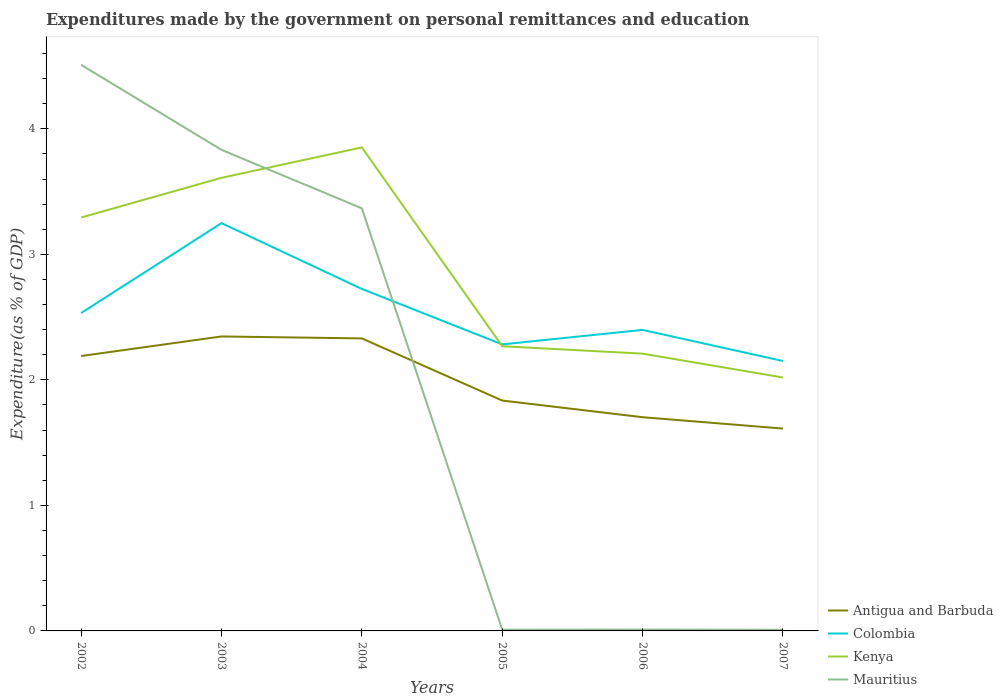Across all years, what is the maximum expenditures made by the government on personal remittances and education in Colombia?
Offer a terse response. 2.15. What is the total expenditures made by the government on personal remittances and education in Colombia in the graph?
Provide a succinct answer. 0.44. What is the difference between the highest and the second highest expenditures made by the government on personal remittances and education in Colombia?
Your response must be concise. 1.1. How many lines are there?
Provide a short and direct response. 4. Does the graph contain grids?
Offer a very short reply. No. Where does the legend appear in the graph?
Make the answer very short. Bottom right. What is the title of the graph?
Provide a succinct answer. Expenditures made by the government on personal remittances and education. What is the label or title of the X-axis?
Provide a succinct answer. Years. What is the label or title of the Y-axis?
Ensure brevity in your answer.  Expenditure(as % of GDP). What is the Expenditure(as % of GDP) of Antigua and Barbuda in 2002?
Offer a very short reply. 2.19. What is the Expenditure(as % of GDP) in Colombia in 2002?
Keep it short and to the point. 2.53. What is the Expenditure(as % of GDP) of Kenya in 2002?
Provide a succinct answer. 3.29. What is the Expenditure(as % of GDP) in Mauritius in 2002?
Provide a succinct answer. 4.51. What is the Expenditure(as % of GDP) of Antigua and Barbuda in 2003?
Keep it short and to the point. 2.35. What is the Expenditure(as % of GDP) in Colombia in 2003?
Your answer should be compact. 3.25. What is the Expenditure(as % of GDP) in Kenya in 2003?
Provide a succinct answer. 3.61. What is the Expenditure(as % of GDP) in Mauritius in 2003?
Offer a very short reply. 3.83. What is the Expenditure(as % of GDP) in Antigua and Barbuda in 2004?
Provide a succinct answer. 2.33. What is the Expenditure(as % of GDP) of Colombia in 2004?
Make the answer very short. 2.72. What is the Expenditure(as % of GDP) in Kenya in 2004?
Ensure brevity in your answer.  3.85. What is the Expenditure(as % of GDP) in Mauritius in 2004?
Provide a succinct answer. 3.37. What is the Expenditure(as % of GDP) in Antigua and Barbuda in 2005?
Your response must be concise. 1.84. What is the Expenditure(as % of GDP) in Colombia in 2005?
Make the answer very short. 2.28. What is the Expenditure(as % of GDP) of Kenya in 2005?
Your answer should be compact. 2.27. What is the Expenditure(as % of GDP) of Mauritius in 2005?
Give a very brief answer. 0.01. What is the Expenditure(as % of GDP) of Antigua and Barbuda in 2006?
Ensure brevity in your answer.  1.7. What is the Expenditure(as % of GDP) in Colombia in 2006?
Offer a terse response. 2.4. What is the Expenditure(as % of GDP) in Kenya in 2006?
Keep it short and to the point. 2.21. What is the Expenditure(as % of GDP) of Mauritius in 2006?
Give a very brief answer. 0.01. What is the Expenditure(as % of GDP) in Antigua and Barbuda in 2007?
Your answer should be compact. 1.61. What is the Expenditure(as % of GDP) in Colombia in 2007?
Give a very brief answer. 2.15. What is the Expenditure(as % of GDP) in Kenya in 2007?
Provide a succinct answer. 2.02. What is the Expenditure(as % of GDP) in Mauritius in 2007?
Provide a short and direct response. 0.01. Across all years, what is the maximum Expenditure(as % of GDP) in Antigua and Barbuda?
Give a very brief answer. 2.35. Across all years, what is the maximum Expenditure(as % of GDP) of Colombia?
Provide a succinct answer. 3.25. Across all years, what is the maximum Expenditure(as % of GDP) in Kenya?
Your answer should be very brief. 3.85. Across all years, what is the maximum Expenditure(as % of GDP) of Mauritius?
Ensure brevity in your answer.  4.51. Across all years, what is the minimum Expenditure(as % of GDP) of Antigua and Barbuda?
Provide a succinct answer. 1.61. Across all years, what is the minimum Expenditure(as % of GDP) of Colombia?
Give a very brief answer. 2.15. Across all years, what is the minimum Expenditure(as % of GDP) in Kenya?
Give a very brief answer. 2.02. Across all years, what is the minimum Expenditure(as % of GDP) in Mauritius?
Offer a very short reply. 0.01. What is the total Expenditure(as % of GDP) in Antigua and Barbuda in the graph?
Provide a short and direct response. 12.02. What is the total Expenditure(as % of GDP) of Colombia in the graph?
Ensure brevity in your answer.  15.34. What is the total Expenditure(as % of GDP) of Kenya in the graph?
Your response must be concise. 17.25. What is the total Expenditure(as % of GDP) in Mauritius in the graph?
Provide a short and direct response. 11.74. What is the difference between the Expenditure(as % of GDP) of Antigua and Barbuda in 2002 and that in 2003?
Make the answer very short. -0.16. What is the difference between the Expenditure(as % of GDP) of Colombia in 2002 and that in 2003?
Your response must be concise. -0.72. What is the difference between the Expenditure(as % of GDP) in Kenya in 2002 and that in 2003?
Your answer should be compact. -0.32. What is the difference between the Expenditure(as % of GDP) in Mauritius in 2002 and that in 2003?
Your response must be concise. 0.68. What is the difference between the Expenditure(as % of GDP) in Antigua and Barbuda in 2002 and that in 2004?
Your response must be concise. -0.14. What is the difference between the Expenditure(as % of GDP) of Colombia in 2002 and that in 2004?
Give a very brief answer. -0.19. What is the difference between the Expenditure(as % of GDP) of Kenya in 2002 and that in 2004?
Offer a terse response. -0.56. What is the difference between the Expenditure(as % of GDP) in Mauritius in 2002 and that in 2004?
Your answer should be very brief. 1.14. What is the difference between the Expenditure(as % of GDP) of Antigua and Barbuda in 2002 and that in 2005?
Your answer should be very brief. 0.35. What is the difference between the Expenditure(as % of GDP) in Colombia in 2002 and that in 2005?
Your answer should be very brief. 0.25. What is the difference between the Expenditure(as % of GDP) of Kenya in 2002 and that in 2005?
Keep it short and to the point. 1.03. What is the difference between the Expenditure(as % of GDP) of Mauritius in 2002 and that in 2005?
Your answer should be very brief. 4.5. What is the difference between the Expenditure(as % of GDP) of Antigua and Barbuda in 2002 and that in 2006?
Provide a short and direct response. 0.49. What is the difference between the Expenditure(as % of GDP) of Colombia in 2002 and that in 2006?
Provide a short and direct response. 0.13. What is the difference between the Expenditure(as % of GDP) of Kenya in 2002 and that in 2006?
Your answer should be compact. 1.08. What is the difference between the Expenditure(as % of GDP) of Mauritius in 2002 and that in 2006?
Give a very brief answer. 4.5. What is the difference between the Expenditure(as % of GDP) of Antigua and Barbuda in 2002 and that in 2007?
Offer a very short reply. 0.58. What is the difference between the Expenditure(as % of GDP) in Colombia in 2002 and that in 2007?
Provide a succinct answer. 0.38. What is the difference between the Expenditure(as % of GDP) in Kenya in 2002 and that in 2007?
Your answer should be very brief. 1.27. What is the difference between the Expenditure(as % of GDP) in Mauritius in 2002 and that in 2007?
Offer a terse response. 4.5. What is the difference between the Expenditure(as % of GDP) of Antigua and Barbuda in 2003 and that in 2004?
Your answer should be very brief. 0.02. What is the difference between the Expenditure(as % of GDP) in Colombia in 2003 and that in 2004?
Your response must be concise. 0.52. What is the difference between the Expenditure(as % of GDP) of Kenya in 2003 and that in 2004?
Provide a short and direct response. -0.24. What is the difference between the Expenditure(as % of GDP) in Mauritius in 2003 and that in 2004?
Ensure brevity in your answer.  0.47. What is the difference between the Expenditure(as % of GDP) of Antigua and Barbuda in 2003 and that in 2005?
Make the answer very short. 0.51. What is the difference between the Expenditure(as % of GDP) in Colombia in 2003 and that in 2005?
Provide a short and direct response. 0.97. What is the difference between the Expenditure(as % of GDP) of Kenya in 2003 and that in 2005?
Offer a very short reply. 1.34. What is the difference between the Expenditure(as % of GDP) of Mauritius in 2003 and that in 2005?
Offer a very short reply. 3.82. What is the difference between the Expenditure(as % of GDP) in Antigua and Barbuda in 2003 and that in 2006?
Your response must be concise. 0.64. What is the difference between the Expenditure(as % of GDP) of Colombia in 2003 and that in 2006?
Your answer should be very brief. 0.85. What is the difference between the Expenditure(as % of GDP) of Kenya in 2003 and that in 2006?
Keep it short and to the point. 1.4. What is the difference between the Expenditure(as % of GDP) in Mauritius in 2003 and that in 2006?
Provide a succinct answer. 3.82. What is the difference between the Expenditure(as % of GDP) of Antigua and Barbuda in 2003 and that in 2007?
Your response must be concise. 0.73. What is the difference between the Expenditure(as % of GDP) of Colombia in 2003 and that in 2007?
Offer a terse response. 1.1. What is the difference between the Expenditure(as % of GDP) in Kenya in 2003 and that in 2007?
Provide a succinct answer. 1.59. What is the difference between the Expenditure(as % of GDP) of Mauritius in 2003 and that in 2007?
Your answer should be compact. 3.82. What is the difference between the Expenditure(as % of GDP) in Antigua and Barbuda in 2004 and that in 2005?
Keep it short and to the point. 0.49. What is the difference between the Expenditure(as % of GDP) of Colombia in 2004 and that in 2005?
Provide a succinct answer. 0.44. What is the difference between the Expenditure(as % of GDP) in Kenya in 2004 and that in 2005?
Provide a short and direct response. 1.58. What is the difference between the Expenditure(as % of GDP) in Mauritius in 2004 and that in 2005?
Ensure brevity in your answer.  3.36. What is the difference between the Expenditure(as % of GDP) in Antigua and Barbuda in 2004 and that in 2006?
Offer a terse response. 0.63. What is the difference between the Expenditure(as % of GDP) of Colombia in 2004 and that in 2006?
Make the answer very short. 0.33. What is the difference between the Expenditure(as % of GDP) in Kenya in 2004 and that in 2006?
Keep it short and to the point. 1.64. What is the difference between the Expenditure(as % of GDP) of Mauritius in 2004 and that in 2006?
Keep it short and to the point. 3.36. What is the difference between the Expenditure(as % of GDP) of Antigua and Barbuda in 2004 and that in 2007?
Ensure brevity in your answer.  0.72. What is the difference between the Expenditure(as % of GDP) in Colombia in 2004 and that in 2007?
Provide a short and direct response. 0.57. What is the difference between the Expenditure(as % of GDP) in Kenya in 2004 and that in 2007?
Your answer should be compact. 1.83. What is the difference between the Expenditure(as % of GDP) in Mauritius in 2004 and that in 2007?
Provide a succinct answer. 3.36. What is the difference between the Expenditure(as % of GDP) in Antigua and Barbuda in 2005 and that in 2006?
Your response must be concise. 0.13. What is the difference between the Expenditure(as % of GDP) of Colombia in 2005 and that in 2006?
Make the answer very short. -0.12. What is the difference between the Expenditure(as % of GDP) of Kenya in 2005 and that in 2006?
Ensure brevity in your answer.  0.06. What is the difference between the Expenditure(as % of GDP) in Mauritius in 2005 and that in 2006?
Ensure brevity in your answer.  -0. What is the difference between the Expenditure(as % of GDP) in Antigua and Barbuda in 2005 and that in 2007?
Make the answer very short. 0.22. What is the difference between the Expenditure(as % of GDP) of Colombia in 2005 and that in 2007?
Provide a short and direct response. 0.13. What is the difference between the Expenditure(as % of GDP) in Kenya in 2005 and that in 2007?
Your answer should be very brief. 0.25. What is the difference between the Expenditure(as % of GDP) in Mauritius in 2005 and that in 2007?
Provide a succinct answer. 0. What is the difference between the Expenditure(as % of GDP) in Antigua and Barbuda in 2006 and that in 2007?
Your answer should be very brief. 0.09. What is the difference between the Expenditure(as % of GDP) of Colombia in 2006 and that in 2007?
Provide a succinct answer. 0.25. What is the difference between the Expenditure(as % of GDP) in Kenya in 2006 and that in 2007?
Your response must be concise. 0.19. What is the difference between the Expenditure(as % of GDP) in Mauritius in 2006 and that in 2007?
Make the answer very short. 0. What is the difference between the Expenditure(as % of GDP) of Antigua and Barbuda in 2002 and the Expenditure(as % of GDP) of Colombia in 2003?
Your answer should be very brief. -1.06. What is the difference between the Expenditure(as % of GDP) in Antigua and Barbuda in 2002 and the Expenditure(as % of GDP) in Kenya in 2003?
Your answer should be compact. -1.42. What is the difference between the Expenditure(as % of GDP) of Antigua and Barbuda in 2002 and the Expenditure(as % of GDP) of Mauritius in 2003?
Your answer should be compact. -1.64. What is the difference between the Expenditure(as % of GDP) of Colombia in 2002 and the Expenditure(as % of GDP) of Kenya in 2003?
Provide a succinct answer. -1.08. What is the difference between the Expenditure(as % of GDP) in Colombia in 2002 and the Expenditure(as % of GDP) in Mauritius in 2003?
Give a very brief answer. -1.3. What is the difference between the Expenditure(as % of GDP) of Kenya in 2002 and the Expenditure(as % of GDP) of Mauritius in 2003?
Your answer should be compact. -0.54. What is the difference between the Expenditure(as % of GDP) of Antigua and Barbuda in 2002 and the Expenditure(as % of GDP) of Colombia in 2004?
Provide a short and direct response. -0.53. What is the difference between the Expenditure(as % of GDP) in Antigua and Barbuda in 2002 and the Expenditure(as % of GDP) in Kenya in 2004?
Offer a very short reply. -1.66. What is the difference between the Expenditure(as % of GDP) in Antigua and Barbuda in 2002 and the Expenditure(as % of GDP) in Mauritius in 2004?
Give a very brief answer. -1.18. What is the difference between the Expenditure(as % of GDP) of Colombia in 2002 and the Expenditure(as % of GDP) of Kenya in 2004?
Offer a terse response. -1.32. What is the difference between the Expenditure(as % of GDP) in Colombia in 2002 and the Expenditure(as % of GDP) in Mauritius in 2004?
Your response must be concise. -0.83. What is the difference between the Expenditure(as % of GDP) in Kenya in 2002 and the Expenditure(as % of GDP) in Mauritius in 2004?
Offer a very short reply. -0.07. What is the difference between the Expenditure(as % of GDP) in Antigua and Barbuda in 2002 and the Expenditure(as % of GDP) in Colombia in 2005?
Keep it short and to the point. -0.09. What is the difference between the Expenditure(as % of GDP) in Antigua and Barbuda in 2002 and the Expenditure(as % of GDP) in Kenya in 2005?
Make the answer very short. -0.08. What is the difference between the Expenditure(as % of GDP) in Antigua and Barbuda in 2002 and the Expenditure(as % of GDP) in Mauritius in 2005?
Provide a succinct answer. 2.18. What is the difference between the Expenditure(as % of GDP) of Colombia in 2002 and the Expenditure(as % of GDP) of Kenya in 2005?
Keep it short and to the point. 0.26. What is the difference between the Expenditure(as % of GDP) of Colombia in 2002 and the Expenditure(as % of GDP) of Mauritius in 2005?
Provide a short and direct response. 2.52. What is the difference between the Expenditure(as % of GDP) in Kenya in 2002 and the Expenditure(as % of GDP) in Mauritius in 2005?
Ensure brevity in your answer.  3.28. What is the difference between the Expenditure(as % of GDP) of Antigua and Barbuda in 2002 and the Expenditure(as % of GDP) of Colombia in 2006?
Keep it short and to the point. -0.21. What is the difference between the Expenditure(as % of GDP) of Antigua and Barbuda in 2002 and the Expenditure(as % of GDP) of Kenya in 2006?
Give a very brief answer. -0.02. What is the difference between the Expenditure(as % of GDP) in Antigua and Barbuda in 2002 and the Expenditure(as % of GDP) in Mauritius in 2006?
Provide a short and direct response. 2.18. What is the difference between the Expenditure(as % of GDP) in Colombia in 2002 and the Expenditure(as % of GDP) in Kenya in 2006?
Offer a very short reply. 0.32. What is the difference between the Expenditure(as % of GDP) of Colombia in 2002 and the Expenditure(as % of GDP) of Mauritius in 2006?
Your answer should be compact. 2.52. What is the difference between the Expenditure(as % of GDP) in Kenya in 2002 and the Expenditure(as % of GDP) in Mauritius in 2006?
Your response must be concise. 3.28. What is the difference between the Expenditure(as % of GDP) of Antigua and Barbuda in 2002 and the Expenditure(as % of GDP) of Colombia in 2007?
Offer a very short reply. 0.04. What is the difference between the Expenditure(as % of GDP) of Antigua and Barbuda in 2002 and the Expenditure(as % of GDP) of Kenya in 2007?
Give a very brief answer. 0.17. What is the difference between the Expenditure(as % of GDP) of Antigua and Barbuda in 2002 and the Expenditure(as % of GDP) of Mauritius in 2007?
Keep it short and to the point. 2.18. What is the difference between the Expenditure(as % of GDP) in Colombia in 2002 and the Expenditure(as % of GDP) in Kenya in 2007?
Offer a very short reply. 0.51. What is the difference between the Expenditure(as % of GDP) in Colombia in 2002 and the Expenditure(as % of GDP) in Mauritius in 2007?
Keep it short and to the point. 2.52. What is the difference between the Expenditure(as % of GDP) of Kenya in 2002 and the Expenditure(as % of GDP) of Mauritius in 2007?
Your answer should be compact. 3.28. What is the difference between the Expenditure(as % of GDP) in Antigua and Barbuda in 2003 and the Expenditure(as % of GDP) in Colombia in 2004?
Your answer should be compact. -0.38. What is the difference between the Expenditure(as % of GDP) in Antigua and Barbuda in 2003 and the Expenditure(as % of GDP) in Kenya in 2004?
Offer a very short reply. -1.51. What is the difference between the Expenditure(as % of GDP) in Antigua and Barbuda in 2003 and the Expenditure(as % of GDP) in Mauritius in 2004?
Provide a short and direct response. -1.02. What is the difference between the Expenditure(as % of GDP) of Colombia in 2003 and the Expenditure(as % of GDP) of Kenya in 2004?
Make the answer very short. -0.6. What is the difference between the Expenditure(as % of GDP) of Colombia in 2003 and the Expenditure(as % of GDP) of Mauritius in 2004?
Ensure brevity in your answer.  -0.12. What is the difference between the Expenditure(as % of GDP) of Kenya in 2003 and the Expenditure(as % of GDP) of Mauritius in 2004?
Your answer should be very brief. 0.24. What is the difference between the Expenditure(as % of GDP) in Antigua and Barbuda in 2003 and the Expenditure(as % of GDP) in Colombia in 2005?
Your answer should be compact. 0.06. What is the difference between the Expenditure(as % of GDP) of Antigua and Barbuda in 2003 and the Expenditure(as % of GDP) of Kenya in 2005?
Provide a short and direct response. 0.08. What is the difference between the Expenditure(as % of GDP) of Antigua and Barbuda in 2003 and the Expenditure(as % of GDP) of Mauritius in 2005?
Your answer should be compact. 2.34. What is the difference between the Expenditure(as % of GDP) of Colombia in 2003 and the Expenditure(as % of GDP) of Kenya in 2005?
Make the answer very short. 0.98. What is the difference between the Expenditure(as % of GDP) in Colombia in 2003 and the Expenditure(as % of GDP) in Mauritius in 2005?
Ensure brevity in your answer.  3.24. What is the difference between the Expenditure(as % of GDP) in Kenya in 2003 and the Expenditure(as % of GDP) in Mauritius in 2005?
Offer a very short reply. 3.6. What is the difference between the Expenditure(as % of GDP) of Antigua and Barbuda in 2003 and the Expenditure(as % of GDP) of Colombia in 2006?
Provide a succinct answer. -0.05. What is the difference between the Expenditure(as % of GDP) of Antigua and Barbuda in 2003 and the Expenditure(as % of GDP) of Kenya in 2006?
Your answer should be very brief. 0.14. What is the difference between the Expenditure(as % of GDP) of Antigua and Barbuda in 2003 and the Expenditure(as % of GDP) of Mauritius in 2006?
Make the answer very short. 2.34. What is the difference between the Expenditure(as % of GDP) in Colombia in 2003 and the Expenditure(as % of GDP) in Kenya in 2006?
Your response must be concise. 1.04. What is the difference between the Expenditure(as % of GDP) in Colombia in 2003 and the Expenditure(as % of GDP) in Mauritius in 2006?
Your answer should be very brief. 3.24. What is the difference between the Expenditure(as % of GDP) in Kenya in 2003 and the Expenditure(as % of GDP) in Mauritius in 2006?
Give a very brief answer. 3.6. What is the difference between the Expenditure(as % of GDP) in Antigua and Barbuda in 2003 and the Expenditure(as % of GDP) in Colombia in 2007?
Offer a terse response. 0.2. What is the difference between the Expenditure(as % of GDP) in Antigua and Barbuda in 2003 and the Expenditure(as % of GDP) in Kenya in 2007?
Your answer should be compact. 0.33. What is the difference between the Expenditure(as % of GDP) in Antigua and Barbuda in 2003 and the Expenditure(as % of GDP) in Mauritius in 2007?
Your answer should be very brief. 2.34. What is the difference between the Expenditure(as % of GDP) of Colombia in 2003 and the Expenditure(as % of GDP) of Kenya in 2007?
Your answer should be very brief. 1.23. What is the difference between the Expenditure(as % of GDP) of Colombia in 2003 and the Expenditure(as % of GDP) of Mauritius in 2007?
Provide a short and direct response. 3.24. What is the difference between the Expenditure(as % of GDP) of Kenya in 2003 and the Expenditure(as % of GDP) of Mauritius in 2007?
Your answer should be very brief. 3.6. What is the difference between the Expenditure(as % of GDP) in Antigua and Barbuda in 2004 and the Expenditure(as % of GDP) in Colombia in 2005?
Keep it short and to the point. 0.05. What is the difference between the Expenditure(as % of GDP) of Antigua and Barbuda in 2004 and the Expenditure(as % of GDP) of Kenya in 2005?
Provide a short and direct response. 0.06. What is the difference between the Expenditure(as % of GDP) of Antigua and Barbuda in 2004 and the Expenditure(as % of GDP) of Mauritius in 2005?
Offer a terse response. 2.32. What is the difference between the Expenditure(as % of GDP) in Colombia in 2004 and the Expenditure(as % of GDP) in Kenya in 2005?
Provide a succinct answer. 0.46. What is the difference between the Expenditure(as % of GDP) in Colombia in 2004 and the Expenditure(as % of GDP) in Mauritius in 2005?
Provide a succinct answer. 2.71. What is the difference between the Expenditure(as % of GDP) of Kenya in 2004 and the Expenditure(as % of GDP) of Mauritius in 2005?
Your answer should be very brief. 3.84. What is the difference between the Expenditure(as % of GDP) in Antigua and Barbuda in 2004 and the Expenditure(as % of GDP) in Colombia in 2006?
Offer a very short reply. -0.07. What is the difference between the Expenditure(as % of GDP) in Antigua and Barbuda in 2004 and the Expenditure(as % of GDP) in Kenya in 2006?
Offer a very short reply. 0.12. What is the difference between the Expenditure(as % of GDP) of Antigua and Barbuda in 2004 and the Expenditure(as % of GDP) of Mauritius in 2006?
Keep it short and to the point. 2.32. What is the difference between the Expenditure(as % of GDP) in Colombia in 2004 and the Expenditure(as % of GDP) in Kenya in 2006?
Ensure brevity in your answer.  0.52. What is the difference between the Expenditure(as % of GDP) of Colombia in 2004 and the Expenditure(as % of GDP) of Mauritius in 2006?
Your answer should be compact. 2.71. What is the difference between the Expenditure(as % of GDP) in Kenya in 2004 and the Expenditure(as % of GDP) in Mauritius in 2006?
Give a very brief answer. 3.84. What is the difference between the Expenditure(as % of GDP) of Antigua and Barbuda in 2004 and the Expenditure(as % of GDP) of Colombia in 2007?
Give a very brief answer. 0.18. What is the difference between the Expenditure(as % of GDP) of Antigua and Barbuda in 2004 and the Expenditure(as % of GDP) of Kenya in 2007?
Ensure brevity in your answer.  0.31. What is the difference between the Expenditure(as % of GDP) of Antigua and Barbuda in 2004 and the Expenditure(as % of GDP) of Mauritius in 2007?
Offer a terse response. 2.32. What is the difference between the Expenditure(as % of GDP) of Colombia in 2004 and the Expenditure(as % of GDP) of Kenya in 2007?
Ensure brevity in your answer.  0.71. What is the difference between the Expenditure(as % of GDP) of Colombia in 2004 and the Expenditure(as % of GDP) of Mauritius in 2007?
Offer a terse response. 2.72. What is the difference between the Expenditure(as % of GDP) in Kenya in 2004 and the Expenditure(as % of GDP) in Mauritius in 2007?
Give a very brief answer. 3.84. What is the difference between the Expenditure(as % of GDP) in Antigua and Barbuda in 2005 and the Expenditure(as % of GDP) in Colombia in 2006?
Offer a very short reply. -0.56. What is the difference between the Expenditure(as % of GDP) of Antigua and Barbuda in 2005 and the Expenditure(as % of GDP) of Kenya in 2006?
Give a very brief answer. -0.37. What is the difference between the Expenditure(as % of GDP) in Antigua and Barbuda in 2005 and the Expenditure(as % of GDP) in Mauritius in 2006?
Your response must be concise. 1.82. What is the difference between the Expenditure(as % of GDP) of Colombia in 2005 and the Expenditure(as % of GDP) of Kenya in 2006?
Provide a succinct answer. 0.07. What is the difference between the Expenditure(as % of GDP) in Colombia in 2005 and the Expenditure(as % of GDP) in Mauritius in 2006?
Provide a short and direct response. 2.27. What is the difference between the Expenditure(as % of GDP) of Kenya in 2005 and the Expenditure(as % of GDP) of Mauritius in 2006?
Offer a terse response. 2.26. What is the difference between the Expenditure(as % of GDP) of Antigua and Barbuda in 2005 and the Expenditure(as % of GDP) of Colombia in 2007?
Provide a succinct answer. -0.32. What is the difference between the Expenditure(as % of GDP) in Antigua and Barbuda in 2005 and the Expenditure(as % of GDP) in Kenya in 2007?
Your answer should be compact. -0.18. What is the difference between the Expenditure(as % of GDP) of Antigua and Barbuda in 2005 and the Expenditure(as % of GDP) of Mauritius in 2007?
Give a very brief answer. 1.83. What is the difference between the Expenditure(as % of GDP) in Colombia in 2005 and the Expenditure(as % of GDP) in Kenya in 2007?
Provide a succinct answer. 0.26. What is the difference between the Expenditure(as % of GDP) in Colombia in 2005 and the Expenditure(as % of GDP) in Mauritius in 2007?
Your answer should be compact. 2.27. What is the difference between the Expenditure(as % of GDP) in Kenya in 2005 and the Expenditure(as % of GDP) in Mauritius in 2007?
Your answer should be compact. 2.26. What is the difference between the Expenditure(as % of GDP) of Antigua and Barbuda in 2006 and the Expenditure(as % of GDP) of Colombia in 2007?
Keep it short and to the point. -0.45. What is the difference between the Expenditure(as % of GDP) in Antigua and Barbuda in 2006 and the Expenditure(as % of GDP) in Kenya in 2007?
Give a very brief answer. -0.32. What is the difference between the Expenditure(as % of GDP) in Antigua and Barbuda in 2006 and the Expenditure(as % of GDP) in Mauritius in 2007?
Offer a terse response. 1.69. What is the difference between the Expenditure(as % of GDP) in Colombia in 2006 and the Expenditure(as % of GDP) in Kenya in 2007?
Your response must be concise. 0.38. What is the difference between the Expenditure(as % of GDP) in Colombia in 2006 and the Expenditure(as % of GDP) in Mauritius in 2007?
Your answer should be compact. 2.39. What is the difference between the Expenditure(as % of GDP) in Kenya in 2006 and the Expenditure(as % of GDP) in Mauritius in 2007?
Offer a terse response. 2.2. What is the average Expenditure(as % of GDP) in Antigua and Barbuda per year?
Your response must be concise. 2. What is the average Expenditure(as % of GDP) in Colombia per year?
Make the answer very short. 2.56. What is the average Expenditure(as % of GDP) in Kenya per year?
Ensure brevity in your answer.  2.88. What is the average Expenditure(as % of GDP) of Mauritius per year?
Make the answer very short. 1.96. In the year 2002, what is the difference between the Expenditure(as % of GDP) of Antigua and Barbuda and Expenditure(as % of GDP) of Colombia?
Your response must be concise. -0.34. In the year 2002, what is the difference between the Expenditure(as % of GDP) in Antigua and Barbuda and Expenditure(as % of GDP) in Kenya?
Provide a succinct answer. -1.1. In the year 2002, what is the difference between the Expenditure(as % of GDP) in Antigua and Barbuda and Expenditure(as % of GDP) in Mauritius?
Give a very brief answer. -2.32. In the year 2002, what is the difference between the Expenditure(as % of GDP) in Colombia and Expenditure(as % of GDP) in Kenya?
Give a very brief answer. -0.76. In the year 2002, what is the difference between the Expenditure(as % of GDP) in Colombia and Expenditure(as % of GDP) in Mauritius?
Offer a very short reply. -1.98. In the year 2002, what is the difference between the Expenditure(as % of GDP) of Kenya and Expenditure(as % of GDP) of Mauritius?
Provide a succinct answer. -1.22. In the year 2003, what is the difference between the Expenditure(as % of GDP) in Antigua and Barbuda and Expenditure(as % of GDP) in Colombia?
Provide a succinct answer. -0.9. In the year 2003, what is the difference between the Expenditure(as % of GDP) in Antigua and Barbuda and Expenditure(as % of GDP) in Kenya?
Provide a short and direct response. -1.26. In the year 2003, what is the difference between the Expenditure(as % of GDP) in Antigua and Barbuda and Expenditure(as % of GDP) in Mauritius?
Your answer should be compact. -1.49. In the year 2003, what is the difference between the Expenditure(as % of GDP) of Colombia and Expenditure(as % of GDP) of Kenya?
Offer a very short reply. -0.36. In the year 2003, what is the difference between the Expenditure(as % of GDP) of Colombia and Expenditure(as % of GDP) of Mauritius?
Provide a short and direct response. -0.58. In the year 2003, what is the difference between the Expenditure(as % of GDP) of Kenya and Expenditure(as % of GDP) of Mauritius?
Offer a very short reply. -0.22. In the year 2004, what is the difference between the Expenditure(as % of GDP) in Antigua and Barbuda and Expenditure(as % of GDP) in Colombia?
Make the answer very short. -0.39. In the year 2004, what is the difference between the Expenditure(as % of GDP) of Antigua and Barbuda and Expenditure(as % of GDP) of Kenya?
Your answer should be very brief. -1.52. In the year 2004, what is the difference between the Expenditure(as % of GDP) in Antigua and Barbuda and Expenditure(as % of GDP) in Mauritius?
Offer a terse response. -1.04. In the year 2004, what is the difference between the Expenditure(as % of GDP) in Colombia and Expenditure(as % of GDP) in Kenya?
Keep it short and to the point. -1.13. In the year 2004, what is the difference between the Expenditure(as % of GDP) of Colombia and Expenditure(as % of GDP) of Mauritius?
Your answer should be compact. -0.64. In the year 2004, what is the difference between the Expenditure(as % of GDP) in Kenya and Expenditure(as % of GDP) in Mauritius?
Ensure brevity in your answer.  0.49. In the year 2005, what is the difference between the Expenditure(as % of GDP) of Antigua and Barbuda and Expenditure(as % of GDP) of Colombia?
Your response must be concise. -0.45. In the year 2005, what is the difference between the Expenditure(as % of GDP) of Antigua and Barbuda and Expenditure(as % of GDP) of Kenya?
Offer a very short reply. -0.43. In the year 2005, what is the difference between the Expenditure(as % of GDP) in Antigua and Barbuda and Expenditure(as % of GDP) in Mauritius?
Provide a short and direct response. 1.83. In the year 2005, what is the difference between the Expenditure(as % of GDP) of Colombia and Expenditure(as % of GDP) of Kenya?
Your response must be concise. 0.01. In the year 2005, what is the difference between the Expenditure(as % of GDP) of Colombia and Expenditure(as % of GDP) of Mauritius?
Make the answer very short. 2.27. In the year 2005, what is the difference between the Expenditure(as % of GDP) of Kenya and Expenditure(as % of GDP) of Mauritius?
Offer a very short reply. 2.26. In the year 2006, what is the difference between the Expenditure(as % of GDP) of Antigua and Barbuda and Expenditure(as % of GDP) of Colombia?
Your answer should be compact. -0.7. In the year 2006, what is the difference between the Expenditure(as % of GDP) in Antigua and Barbuda and Expenditure(as % of GDP) in Kenya?
Offer a terse response. -0.51. In the year 2006, what is the difference between the Expenditure(as % of GDP) of Antigua and Barbuda and Expenditure(as % of GDP) of Mauritius?
Provide a short and direct response. 1.69. In the year 2006, what is the difference between the Expenditure(as % of GDP) in Colombia and Expenditure(as % of GDP) in Kenya?
Offer a very short reply. 0.19. In the year 2006, what is the difference between the Expenditure(as % of GDP) of Colombia and Expenditure(as % of GDP) of Mauritius?
Keep it short and to the point. 2.39. In the year 2006, what is the difference between the Expenditure(as % of GDP) in Kenya and Expenditure(as % of GDP) in Mauritius?
Your answer should be very brief. 2.2. In the year 2007, what is the difference between the Expenditure(as % of GDP) in Antigua and Barbuda and Expenditure(as % of GDP) in Colombia?
Make the answer very short. -0.54. In the year 2007, what is the difference between the Expenditure(as % of GDP) in Antigua and Barbuda and Expenditure(as % of GDP) in Kenya?
Your answer should be very brief. -0.41. In the year 2007, what is the difference between the Expenditure(as % of GDP) in Antigua and Barbuda and Expenditure(as % of GDP) in Mauritius?
Your answer should be compact. 1.6. In the year 2007, what is the difference between the Expenditure(as % of GDP) in Colombia and Expenditure(as % of GDP) in Kenya?
Give a very brief answer. 0.13. In the year 2007, what is the difference between the Expenditure(as % of GDP) of Colombia and Expenditure(as % of GDP) of Mauritius?
Your answer should be compact. 2.14. In the year 2007, what is the difference between the Expenditure(as % of GDP) of Kenya and Expenditure(as % of GDP) of Mauritius?
Your answer should be very brief. 2.01. What is the ratio of the Expenditure(as % of GDP) in Antigua and Barbuda in 2002 to that in 2003?
Your answer should be very brief. 0.93. What is the ratio of the Expenditure(as % of GDP) in Colombia in 2002 to that in 2003?
Provide a succinct answer. 0.78. What is the ratio of the Expenditure(as % of GDP) in Kenya in 2002 to that in 2003?
Your answer should be very brief. 0.91. What is the ratio of the Expenditure(as % of GDP) of Mauritius in 2002 to that in 2003?
Your answer should be compact. 1.18. What is the ratio of the Expenditure(as % of GDP) of Antigua and Barbuda in 2002 to that in 2004?
Provide a short and direct response. 0.94. What is the ratio of the Expenditure(as % of GDP) of Colombia in 2002 to that in 2004?
Make the answer very short. 0.93. What is the ratio of the Expenditure(as % of GDP) of Kenya in 2002 to that in 2004?
Your answer should be very brief. 0.85. What is the ratio of the Expenditure(as % of GDP) in Mauritius in 2002 to that in 2004?
Provide a short and direct response. 1.34. What is the ratio of the Expenditure(as % of GDP) in Antigua and Barbuda in 2002 to that in 2005?
Offer a terse response. 1.19. What is the ratio of the Expenditure(as % of GDP) in Colombia in 2002 to that in 2005?
Ensure brevity in your answer.  1.11. What is the ratio of the Expenditure(as % of GDP) in Kenya in 2002 to that in 2005?
Give a very brief answer. 1.45. What is the ratio of the Expenditure(as % of GDP) of Mauritius in 2002 to that in 2005?
Your response must be concise. 465.19. What is the ratio of the Expenditure(as % of GDP) in Antigua and Barbuda in 2002 to that in 2006?
Give a very brief answer. 1.29. What is the ratio of the Expenditure(as % of GDP) of Colombia in 2002 to that in 2006?
Your answer should be compact. 1.06. What is the ratio of the Expenditure(as % of GDP) in Kenya in 2002 to that in 2006?
Give a very brief answer. 1.49. What is the ratio of the Expenditure(as % of GDP) of Mauritius in 2002 to that in 2006?
Your answer should be compact. 416.55. What is the ratio of the Expenditure(as % of GDP) of Antigua and Barbuda in 2002 to that in 2007?
Your answer should be very brief. 1.36. What is the ratio of the Expenditure(as % of GDP) of Colombia in 2002 to that in 2007?
Provide a short and direct response. 1.18. What is the ratio of the Expenditure(as % of GDP) of Kenya in 2002 to that in 2007?
Give a very brief answer. 1.63. What is the ratio of the Expenditure(as % of GDP) in Mauritius in 2002 to that in 2007?
Make the answer very short. 499.45. What is the ratio of the Expenditure(as % of GDP) of Colombia in 2003 to that in 2004?
Your response must be concise. 1.19. What is the ratio of the Expenditure(as % of GDP) in Kenya in 2003 to that in 2004?
Ensure brevity in your answer.  0.94. What is the ratio of the Expenditure(as % of GDP) in Mauritius in 2003 to that in 2004?
Offer a terse response. 1.14. What is the ratio of the Expenditure(as % of GDP) of Antigua and Barbuda in 2003 to that in 2005?
Keep it short and to the point. 1.28. What is the ratio of the Expenditure(as % of GDP) of Colombia in 2003 to that in 2005?
Offer a very short reply. 1.42. What is the ratio of the Expenditure(as % of GDP) in Kenya in 2003 to that in 2005?
Ensure brevity in your answer.  1.59. What is the ratio of the Expenditure(as % of GDP) in Mauritius in 2003 to that in 2005?
Offer a terse response. 395.33. What is the ratio of the Expenditure(as % of GDP) in Antigua and Barbuda in 2003 to that in 2006?
Provide a short and direct response. 1.38. What is the ratio of the Expenditure(as % of GDP) in Colombia in 2003 to that in 2006?
Give a very brief answer. 1.35. What is the ratio of the Expenditure(as % of GDP) of Kenya in 2003 to that in 2006?
Make the answer very short. 1.63. What is the ratio of the Expenditure(as % of GDP) of Mauritius in 2003 to that in 2006?
Offer a terse response. 353.99. What is the ratio of the Expenditure(as % of GDP) in Antigua and Barbuda in 2003 to that in 2007?
Keep it short and to the point. 1.46. What is the ratio of the Expenditure(as % of GDP) in Colombia in 2003 to that in 2007?
Your answer should be compact. 1.51. What is the ratio of the Expenditure(as % of GDP) in Kenya in 2003 to that in 2007?
Your answer should be compact. 1.79. What is the ratio of the Expenditure(as % of GDP) of Mauritius in 2003 to that in 2007?
Give a very brief answer. 424.44. What is the ratio of the Expenditure(as % of GDP) of Antigua and Barbuda in 2004 to that in 2005?
Provide a short and direct response. 1.27. What is the ratio of the Expenditure(as % of GDP) in Colombia in 2004 to that in 2005?
Your response must be concise. 1.19. What is the ratio of the Expenditure(as % of GDP) of Kenya in 2004 to that in 2005?
Ensure brevity in your answer.  1.7. What is the ratio of the Expenditure(as % of GDP) in Mauritius in 2004 to that in 2005?
Ensure brevity in your answer.  347.29. What is the ratio of the Expenditure(as % of GDP) of Antigua and Barbuda in 2004 to that in 2006?
Give a very brief answer. 1.37. What is the ratio of the Expenditure(as % of GDP) of Colombia in 2004 to that in 2006?
Offer a very short reply. 1.14. What is the ratio of the Expenditure(as % of GDP) in Kenya in 2004 to that in 2006?
Give a very brief answer. 1.74. What is the ratio of the Expenditure(as % of GDP) in Mauritius in 2004 to that in 2006?
Make the answer very short. 310.98. What is the ratio of the Expenditure(as % of GDP) in Antigua and Barbuda in 2004 to that in 2007?
Your answer should be very brief. 1.45. What is the ratio of the Expenditure(as % of GDP) of Colombia in 2004 to that in 2007?
Make the answer very short. 1.27. What is the ratio of the Expenditure(as % of GDP) of Kenya in 2004 to that in 2007?
Ensure brevity in your answer.  1.91. What is the ratio of the Expenditure(as % of GDP) of Mauritius in 2004 to that in 2007?
Your answer should be compact. 372.87. What is the ratio of the Expenditure(as % of GDP) in Antigua and Barbuda in 2005 to that in 2006?
Your answer should be compact. 1.08. What is the ratio of the Expenditure(as % of GDP) in Colombia in 2005 to that in 2006?
Give a very brief answer. 0.95. What is the ratio of the Expenditure(as % of GDP) in Kenya in 2005 to that in 2006?
Keep it short and to the point. 1.03. What is the ratio of the Expenditure(as % of GDP) in Mauritius in 2005 to that in 2006?
Offer a very short reply. 0.9. What is the ratio of the Expenditure(as % of GDP) of Antigua and Barbuda in 2005 to that in 2007?
Offer a very short reply. 1.14. What is the ratio of the Expenditure(as % of GDP) of Colombia in 2005 to that in 2007?
Offer a very short reply. 1.06. What is the ratio of the Expenditure(as % of GDP) of Kenya in 2005 to that in 2007?
Your answer should be compact. 1.12. What is the ratio of the Expenditure(as % of GDP) of Mauritius in 2005 to that in 2007?
Your response must be concise. 1.07. What is the ratio of the Expenditure(as % of GDP) of Antigua and Barbuda in 2006 to that in 2007?
Ensure brevity in your answer.  1.06. What is the ratio of the Expenditure(as % of GDP) in Colombia in 2006 to that in 2007?
Offer a very short reply. 1.12. What is the ratio of the Expenditure(as % of GDP) in Kenya in 2006 to that in 2007?
Your response must be concise. 1.09. What is the ratio of the Expenditure(as % of GDP) of Mauritius in 2006 to that in 2007?
Give a very brief answer. 1.2. What is the difference between the highest and the second highest Expenditure(as % of GDP) of Antigua and Barbuda?
Give a very brief answer. 0.02. What is the difference between the highest and the second highest Expenditure(as % of GDP) in Colombia?
Your response must be concise. 0.52. What is the difference between the highest and the second highest Expenditure(as % of GDP) of Kenya?
Keep it short and to the point. 0.24. What is the difference between the highest and the second highest Expenditure(as % of GDP) of Mauritius?
Give a very brief answer. 0.68. What is the difference between the highest and the lowest Expenditure(as % of GDP) of Antigua and Barbuda?
Ensure brevity in your answer.  0.73. What is the difference between the highest and the lowest Expenditure(as % of GDP) of Colombia?
Keep it short and to the point. 1.1. What is the difference between the highest and the lowest Expenditure(as % of GDP) of Kenya?
Provide a succinct answer. 1.83. What is the difference between the highest and the lowest Expenditure(as % of GDP) of Mauritius?
Provide a short and direct response. 4.5. 